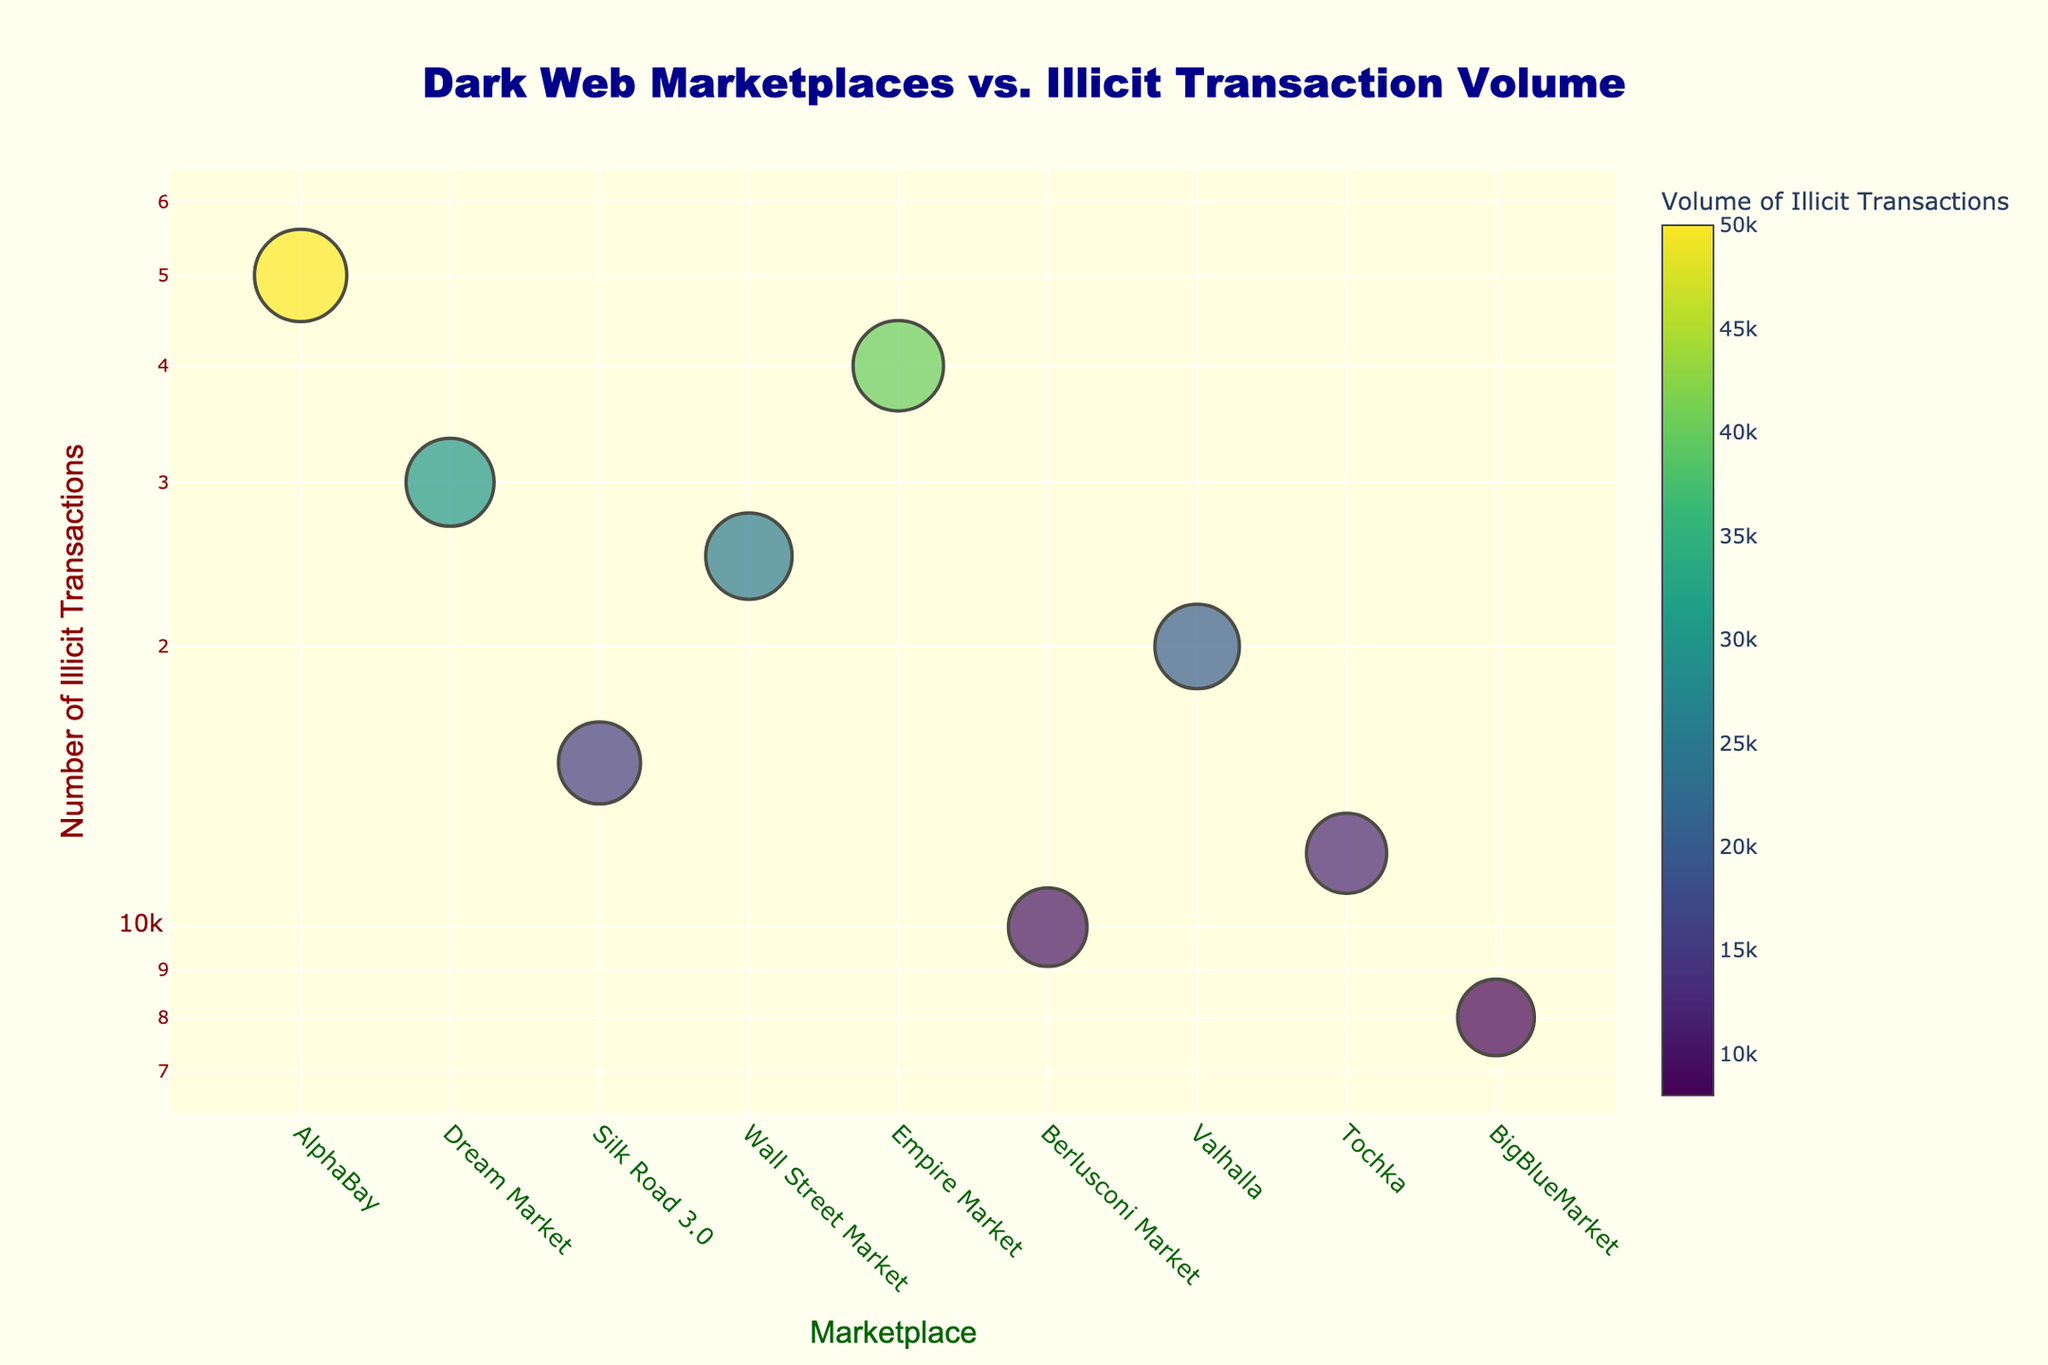What is the title of the scatter plot? The title is positioned at the top of the scatter plot, and it’s quite large and noticeable. It's written as ‘Dark Web Marketplaces vs. Illicit Transaction Volume’.
Answer: Dark Web Marketplaces vs. Illicit Transaction Volume Which marketplace has the highest volume of illicit transactions? By looking at the scatter plot and the hover text, the marker with the highest y-value corresponds to AlphaBay.
Answer: AlphaBay How many marketplaces are represented in the scatter plot? Each data point on the x-axis corresponds to a different marketplace. Counting the distinct markers reveals the total number of unique marketplaces displayed.
Answer: 9 What is the volume of illicit transactions for Dream Market? Hovering over the data points, you can find that Dream Market has an illicit transaction volume, indicated in the hover template text, of 30,000 transactions.
Answer: 30,000 Which market has the smallest volume of illicit transactions, and what is it? Observing the y-axis values and the relative size/color of the markers, the smallest volume corresponds to BigBlueMarket, which has an illicit transaction volume of 8,000.
Answer: BigBlueMarket, 8,000 How does the size of the markers relate to the volume of illicit transactions? The size of each marker is determined by the logarithm of the volume of illicit transactions. Larger marker sizes correspond to higher volumes of illicit transactions.
Answer: Logarithmically related Compare the volume of illicit transactions for AlphaBay and Wall Street Market. The hover text provides exact numbers, with AlphaBay having 50,000 transactions and Wall Street Market having 25,000 transactions. The difference is 50,000 - 25,000 = 25,000 transactions.
Answer: AlphaBay has 25,000 more illicit transactions than Wall Street Market What color represents the highest volume of transactions, and which marketplace does it belong to? The color scale used (Viridis) assigns lighter colors to higher values. AlphaBay, which has the highest volume of 50,000 transactions, is represented with a lighter (close to yellow) marker.
Answer: Light color, AlphaBay What is the approximate average number of illicit transactions across all marketplaces? Summing up all transactions (50000 + 30000 + 15000 + 25000 + 40000 + 10000 + 20000 + 12000 + 8000 = 210000) and dividing by the number of marketplaces (9) gives the average: 210000 / 9 ≈ 23,333 illicit transactions.
Answer: Approximately 23,333 What is the ratio of the highest to the lowest number of illicit transactions? The highest number of illicit transactions is for AlphaBay (50,000) and the lowest for BigBlueMarket (8,000). The ratio is 50,000 / 8,000 = 6.25.
Answer: 6.25 